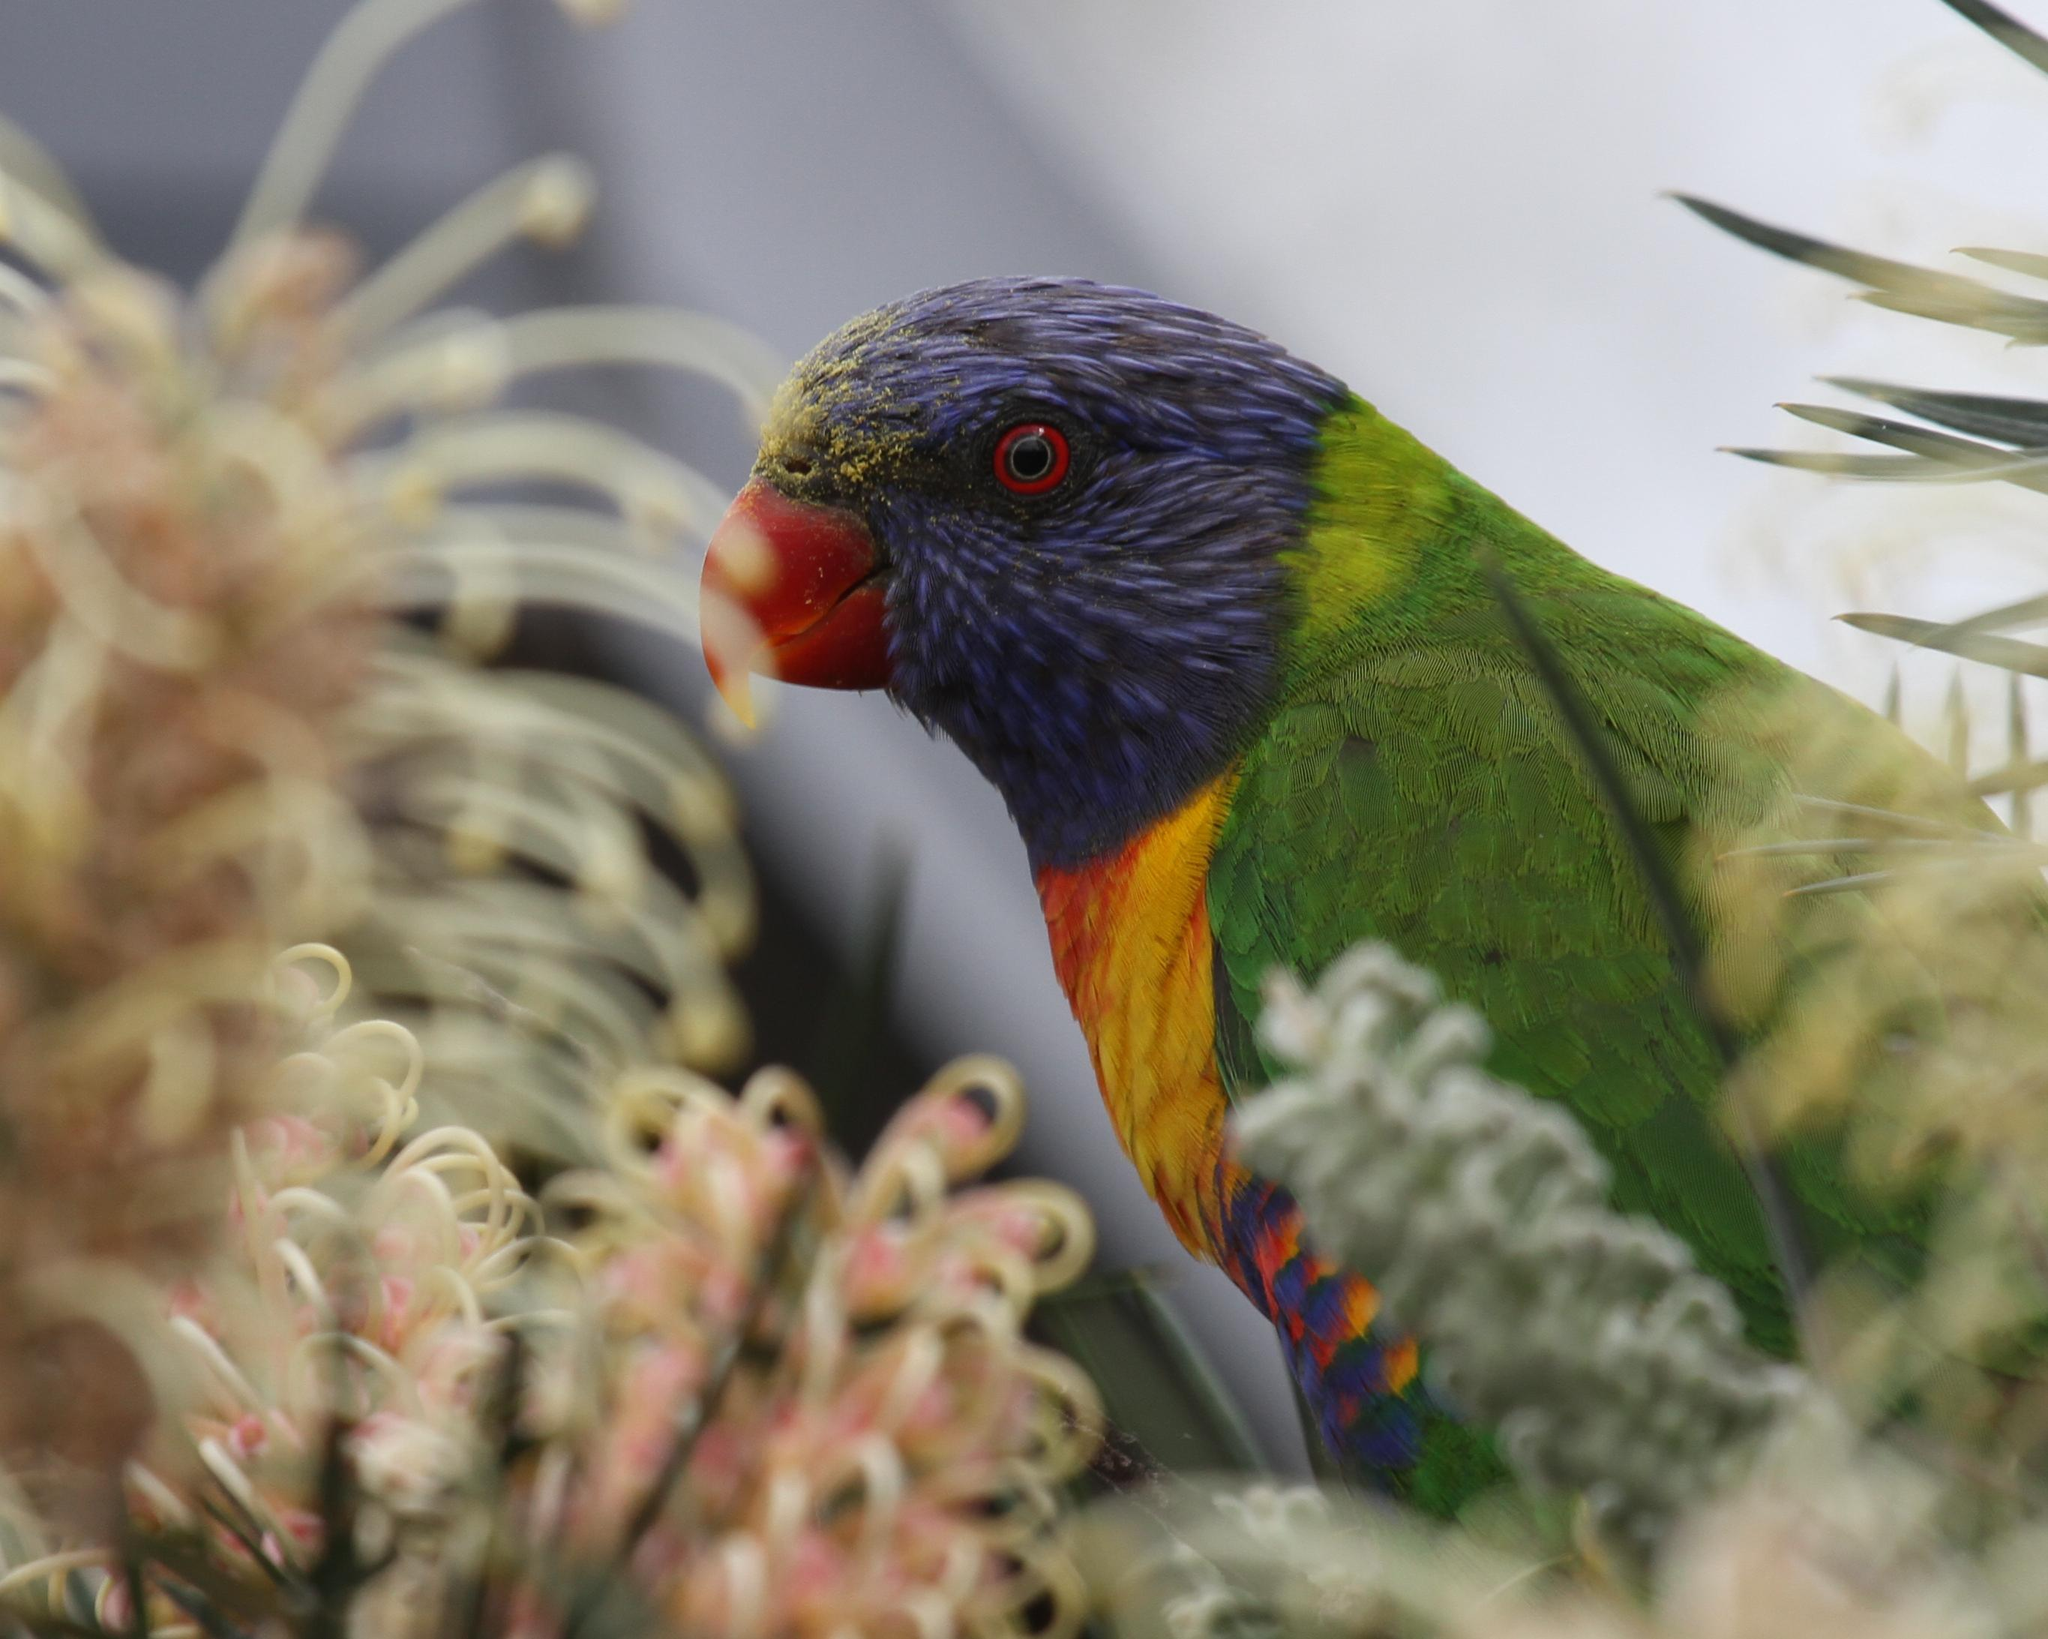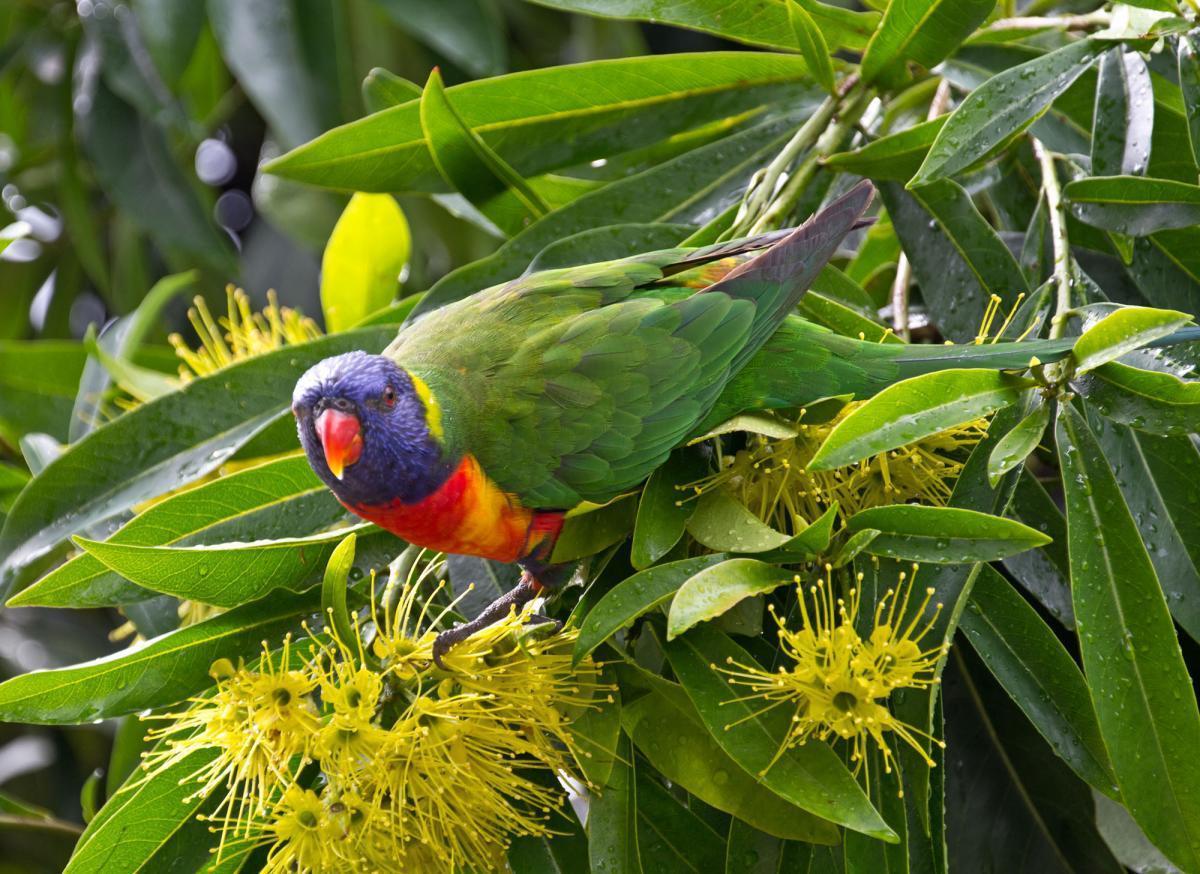The first image is the image on the left, the second image is the image on the right. Evaluate the accuracy of this statement regarding the images: "There are at least two colorful parrots in the right image.". Is it true? Answer yes or no. No. The first image is the image on the left, the second image is the image on the right. For the images displayed, is the sentence "Each image contains a single bird, and at least one bird is pictured near a flower with tendril-like petals." factually correct? Answer yes or no. Yes. 